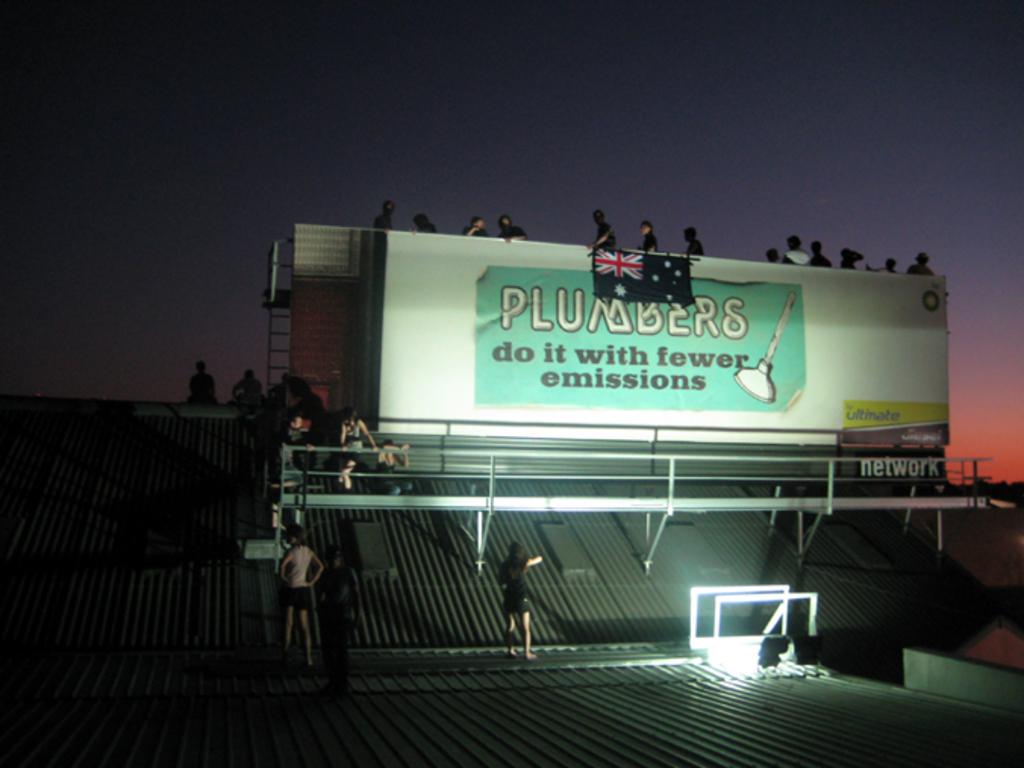What word is in the far right bottom corner?
Your answer should be very brief. Network. 